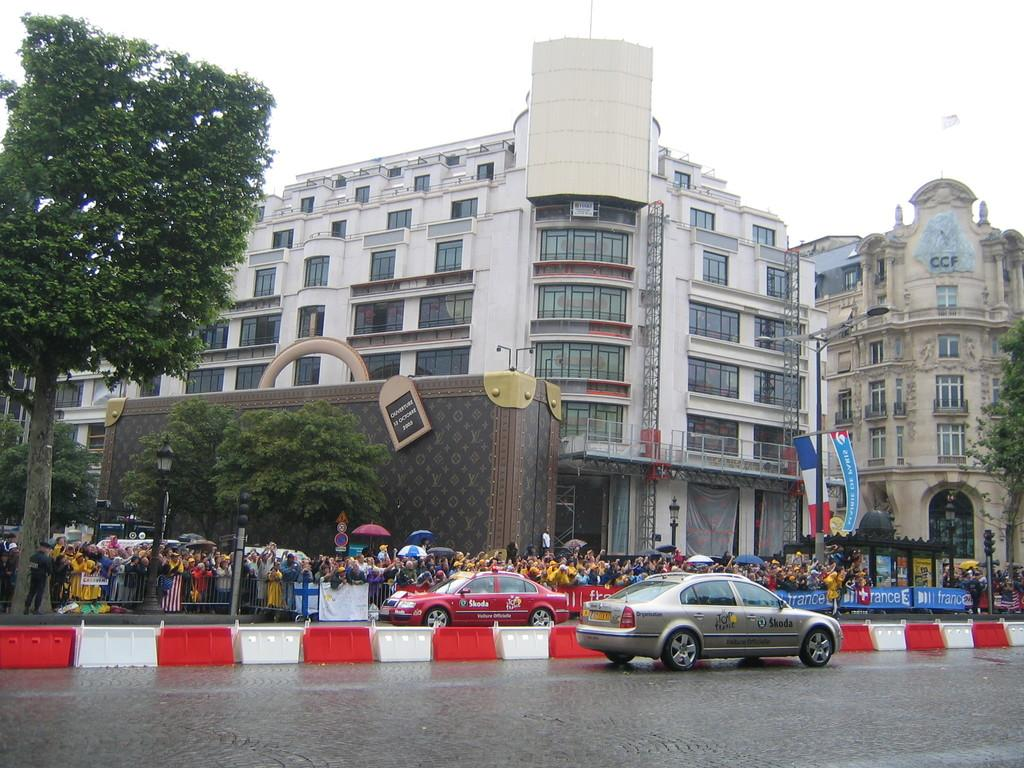<image>
Describe the image concisely. A city scene with a silver car in the foreground that says Skoda. 